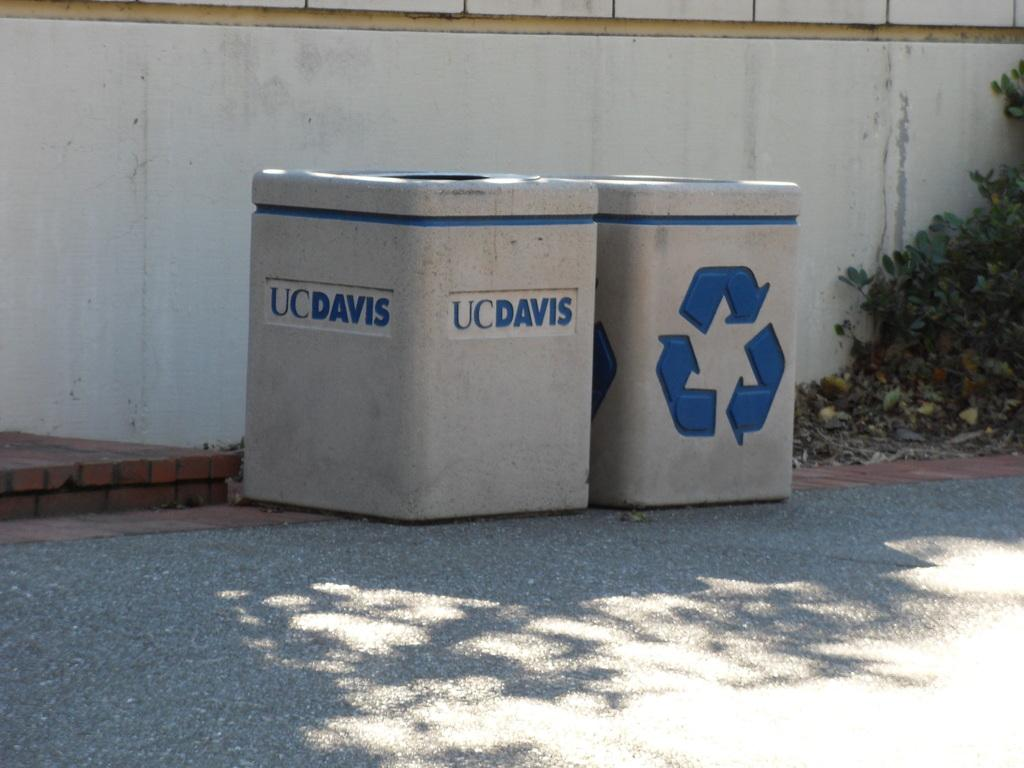<image>
Relay a brief, clear account of the picture shown. Gray bins that says UC Davis on the front. 